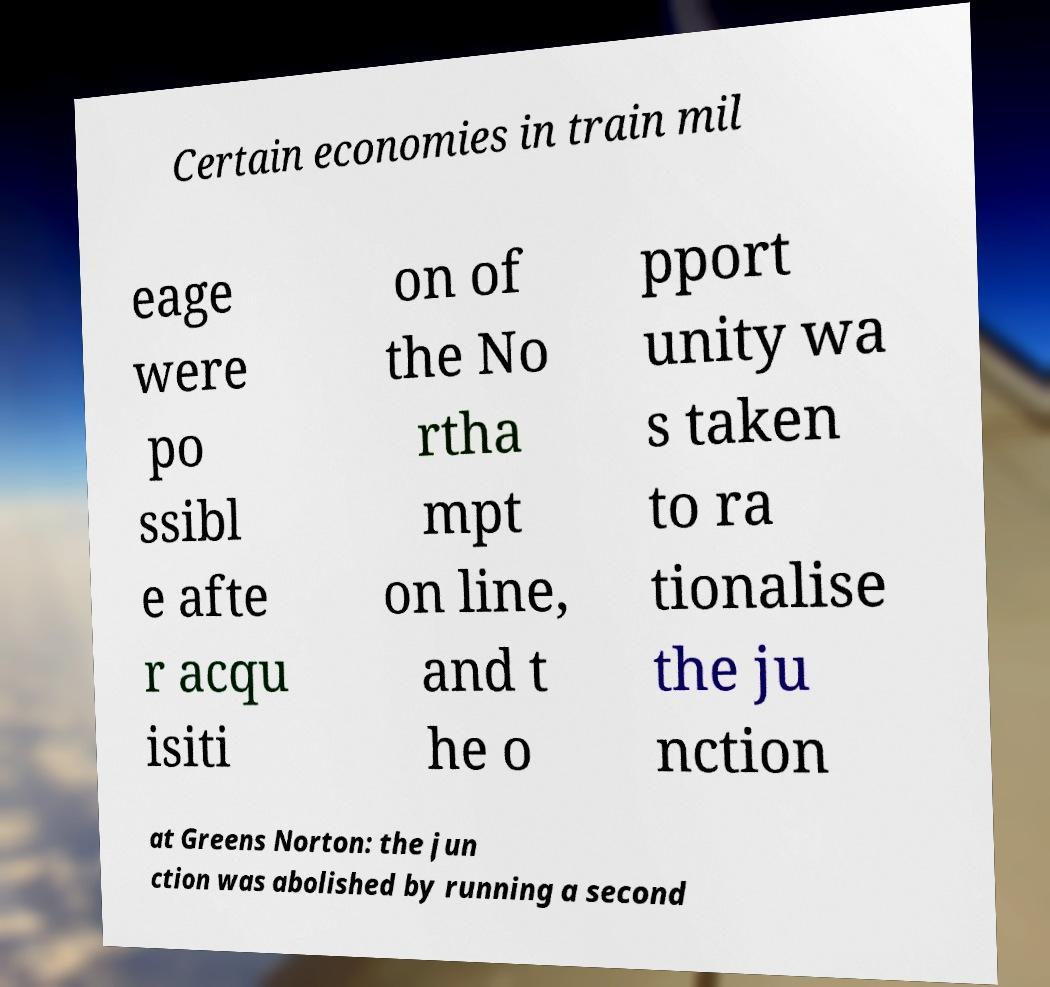For documentation purposes, I need the text within this image transcribed. Could you provide that? Certain economies in train mil eage were po ssibl e afte r acqu isiti on of the No rtha mpt on line, and t he o pport unity wa s taken to ra tionalise the ju nction at Greens Norton: the jun ction was abolished by running a second 